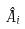<formula> <loc_0><loc_0><loc_500><loc_500>\hat { A } _ { i }</formula> 